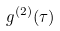Convert formula to latex. <formula><loc_0><loc_0><loc_500><loc_500>g ^ { ( 2 ) } ( \tau )</formula> 